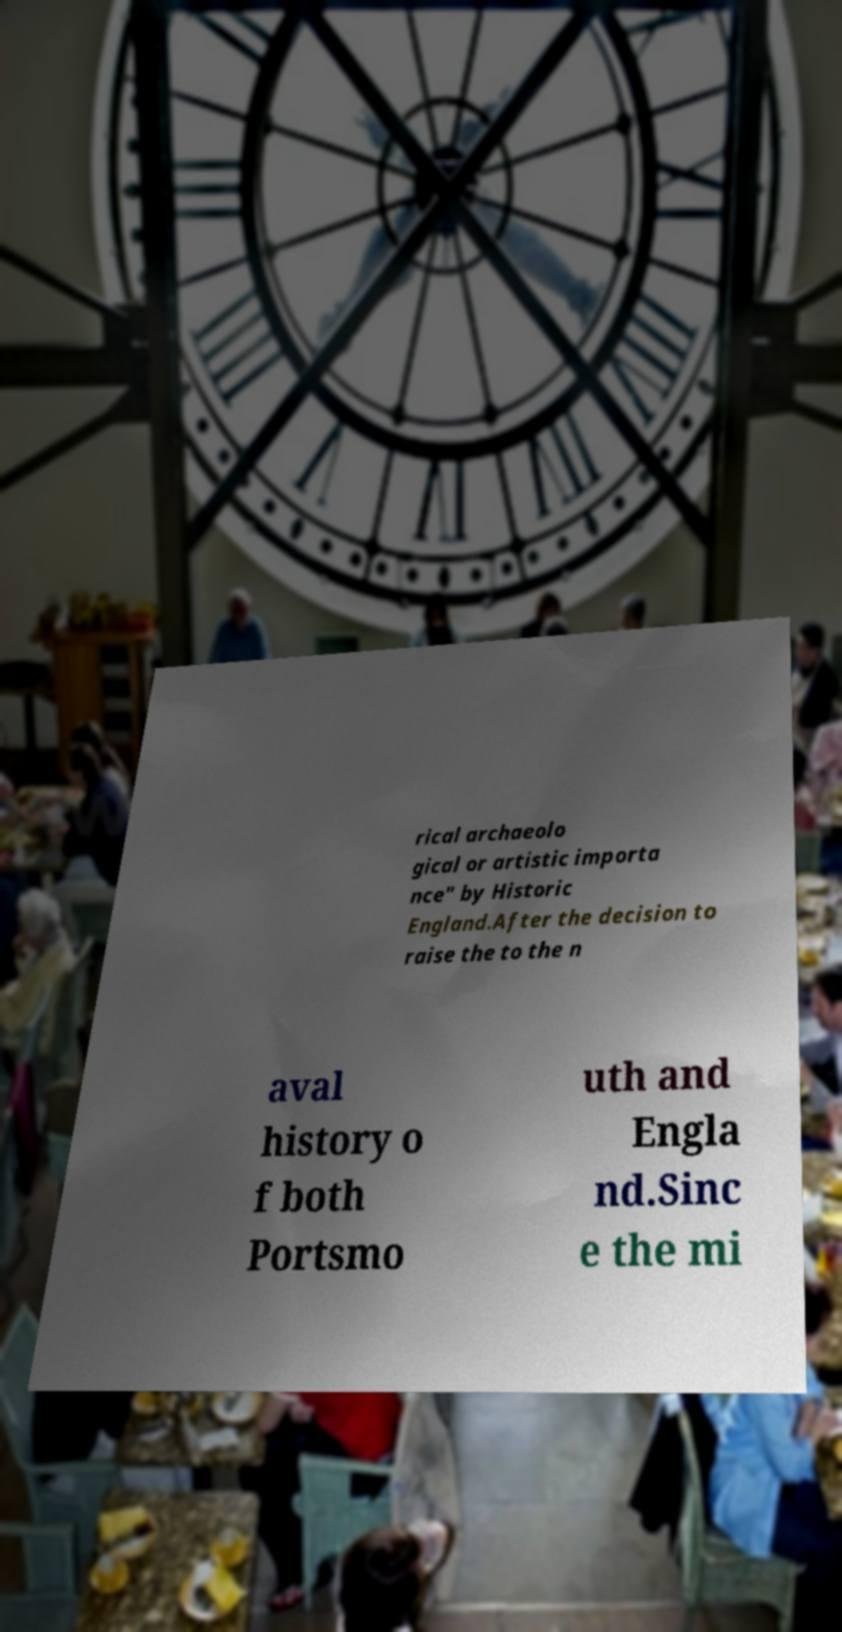What messages or text are displayed in this image? I need them in a readable, typed format. rical archaeolo gical or artistic importa nce" by Historic England.After the decision to raise the to the n aval history o f both Portsmo uth and Engla nd.Sinc e the mi 